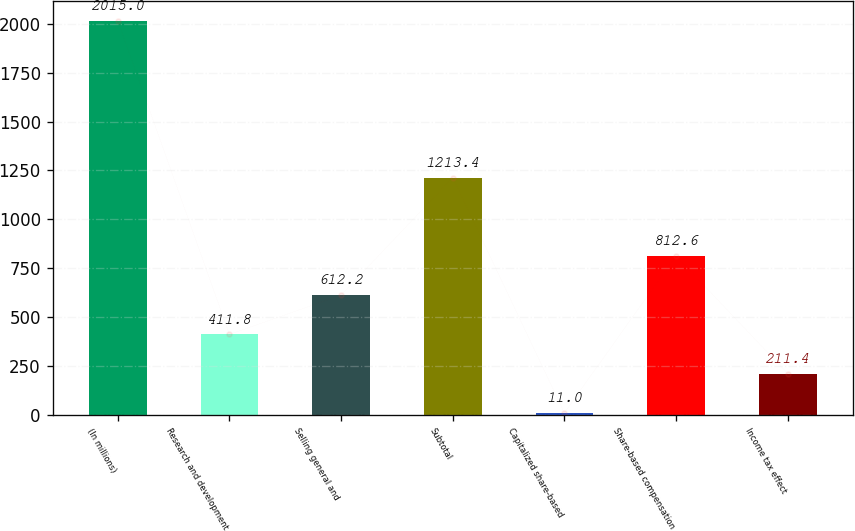Convert chart. <chart><loc_0><loc_0><loc_500><loc_500><bar_chart><fcel>(In millions)<fcel>Research and development<fcel>Selling general and<fcel>Subtotal<fcel>Capitalized share-based<fcel>Share-based compensation<fcel>Income tax effect<nl><fcel>2015<fcel>411.8<fcel>612.2<fcel>1213.4<fcel>11<fcel>812.6<fcel>211.4<nl></chart> 